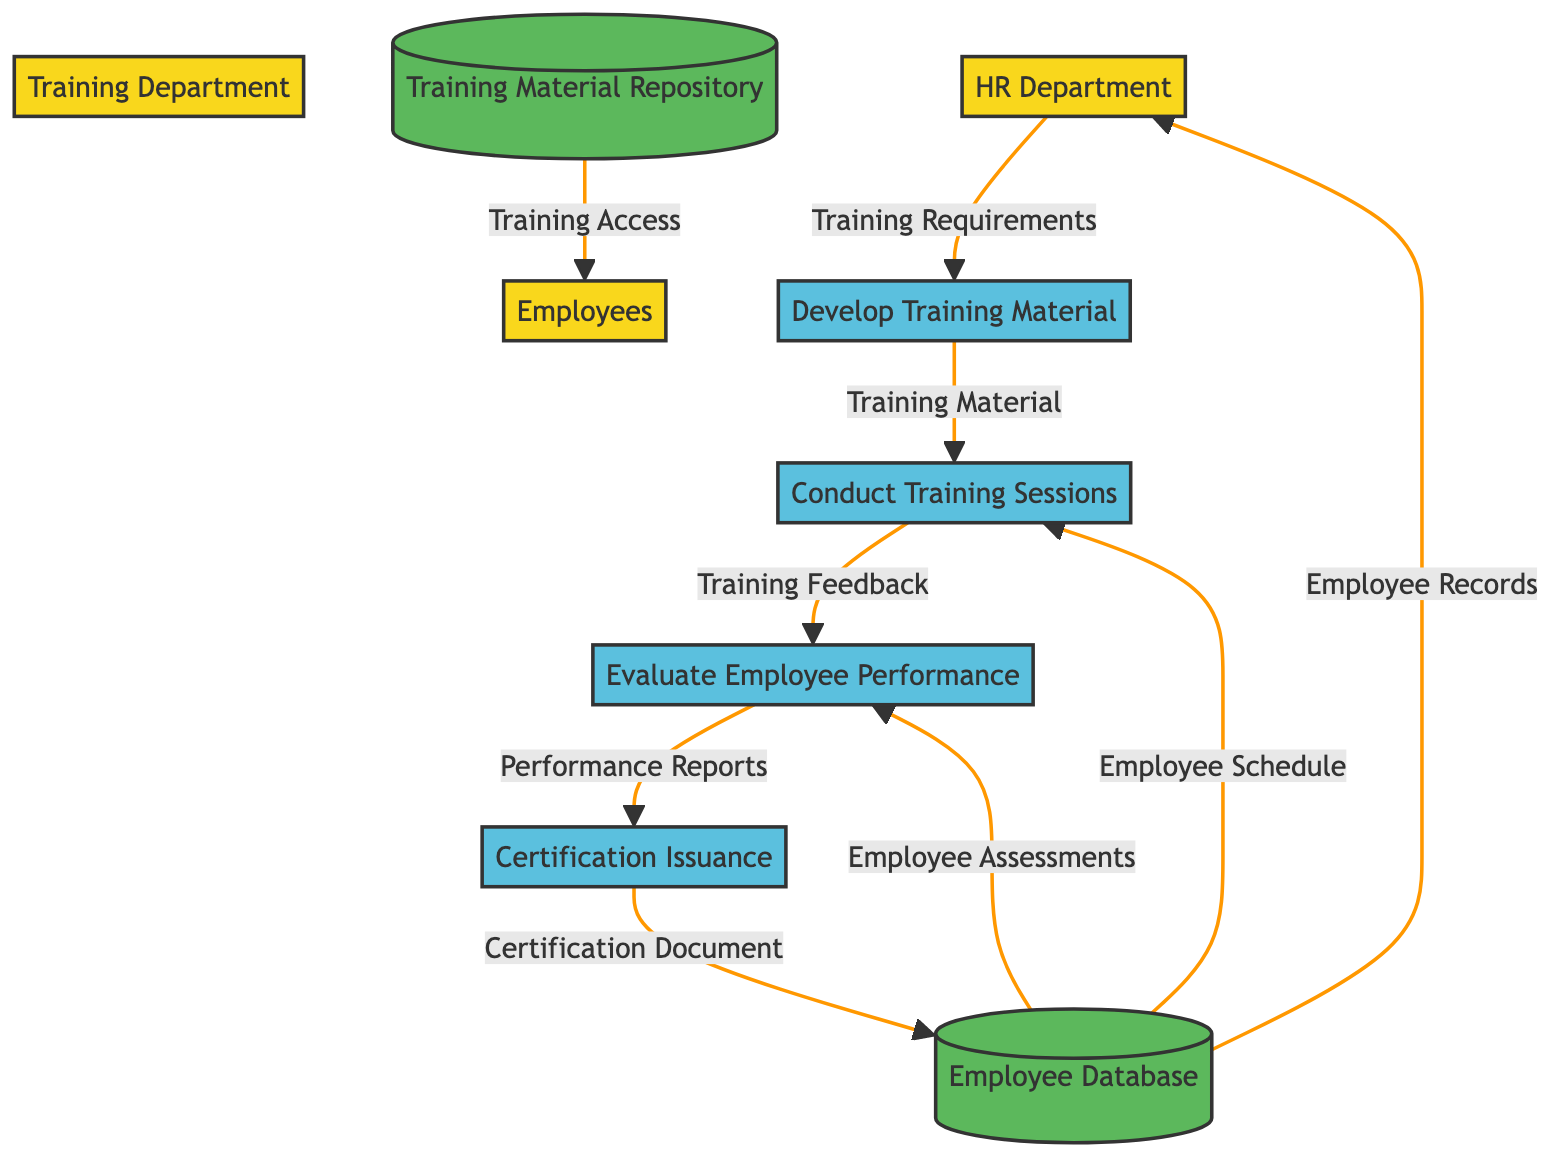What is the first process in this workflow? The first process in the workflow is identified as "Develop Training Material," which follows the data flow from the HR Department regarding Training Requirements.
Answer: Develop Training Material Who provides the Training Requirements? The source of the Training Requirements is the HR Department, which initiates the workflow by sending this information to the Training Department.
Answer: HR Department How many data stores are present in the diagram? Upon reviewing the diagram, there are two data stores present: the Employee Database and the Training Material Repository.
Answer: 2 What is the output of the Certification Issuance process? The output generated by the Certification Issuance process is the Certification Document, which is issued based on the Performance Reports obtained from the previous process.
Answer: Certification Document Which process receives Training Feedback as input? The process that receives Training Feedback as input is "Evaluate Employee Performance." This feedback is crucial for assessing the effectiveness of the training conducted.
Answer: Evaluate Employee Performance What type of relationship exists between the Training Department and the HR Department? The relationship is a data flow, where the HR Department sends Training Requirements to the Training Department, indicating a directional flow of information.
Answer: Data flow What is the destination of the Employee Records output? The Employee Records from the Employee Database are sent to the HR Department, indicating that this is where they are filed for further reference and management.
Answer: HR Department Which process utilizes Employee Assessments as input? "Evaluate Employee Performance" is the process that utilizes Employee Assessments as input, showing it plays a role in performance evaluations following training sessions.
Answer: Evaluate Employee Performance What are the outputs of the Conduct Training Sessions process? The Conduct Training Sessions process outputs Training Feedback, which is crucial for the subsequent evaluation of employee performance.
Answer: Training Feedback 